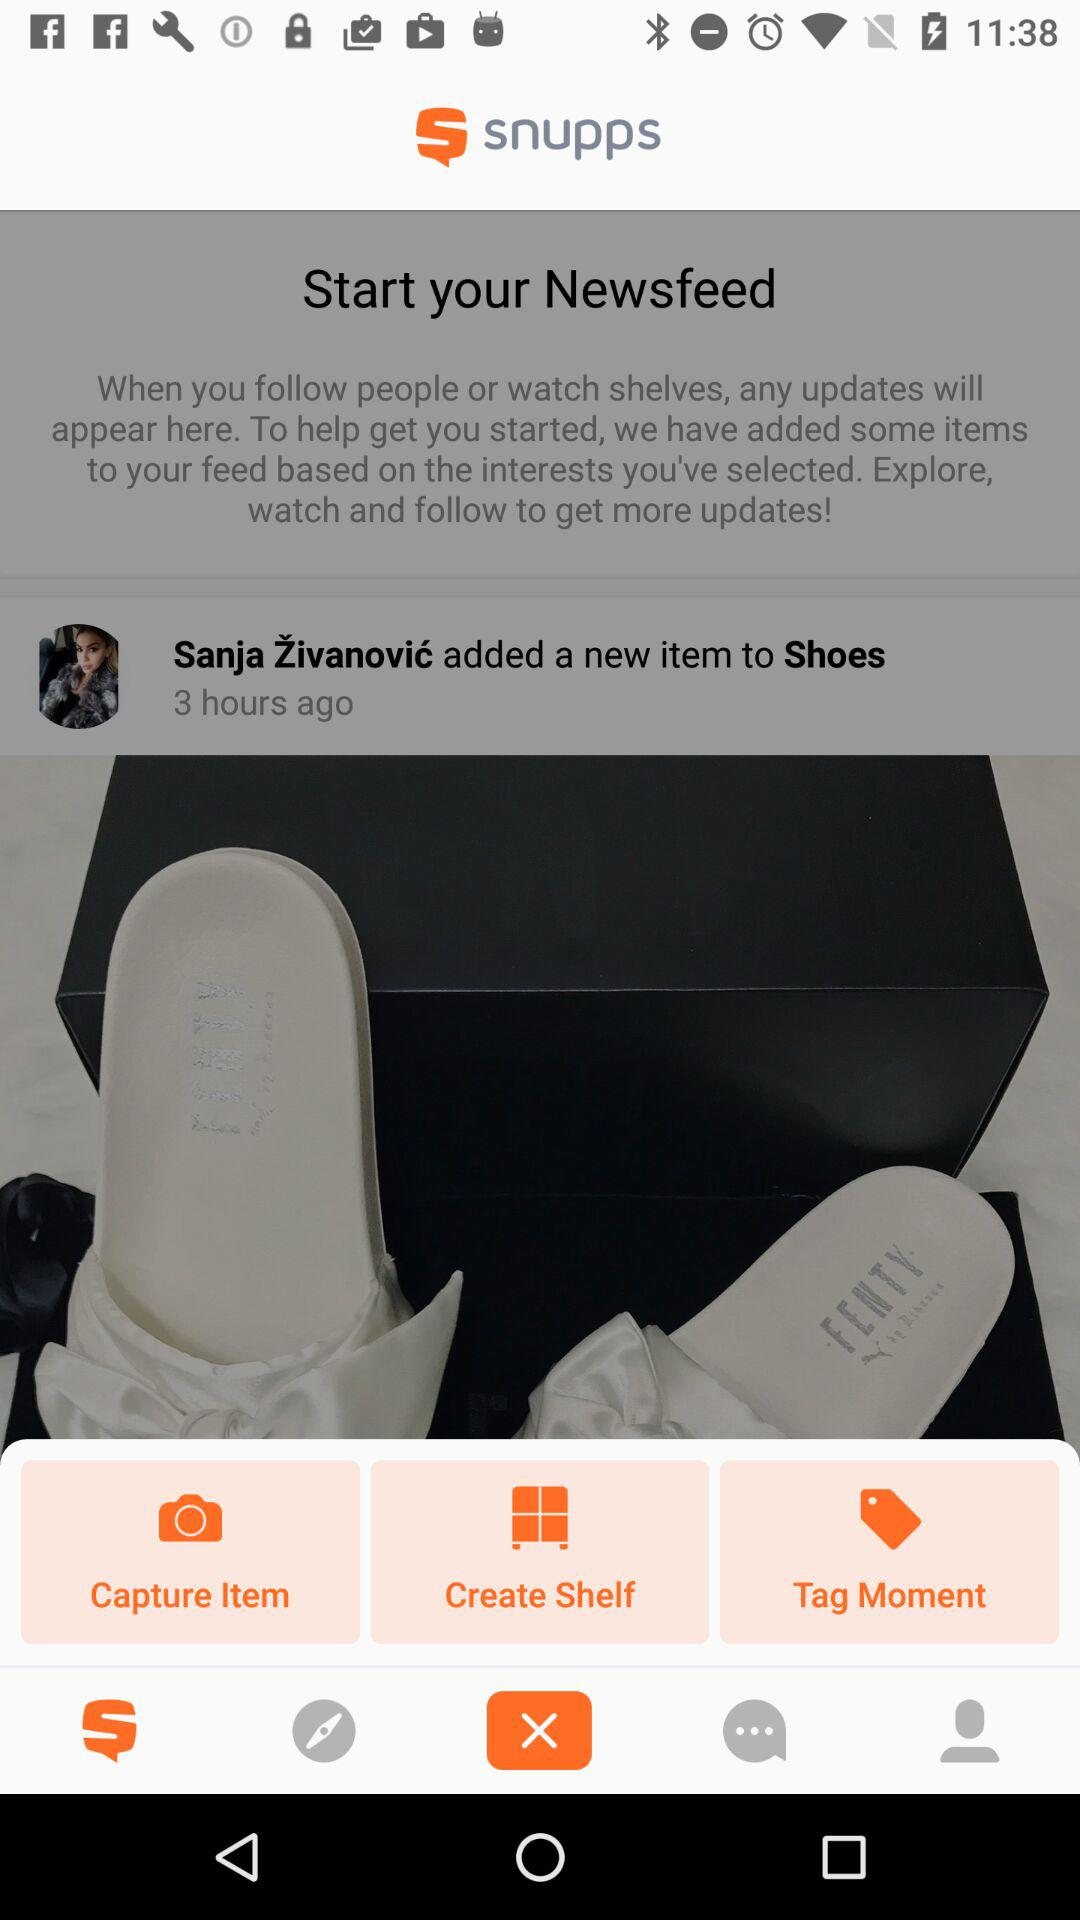How many hours ago was the last update?
Answer the question using a single word or phrase. 3 